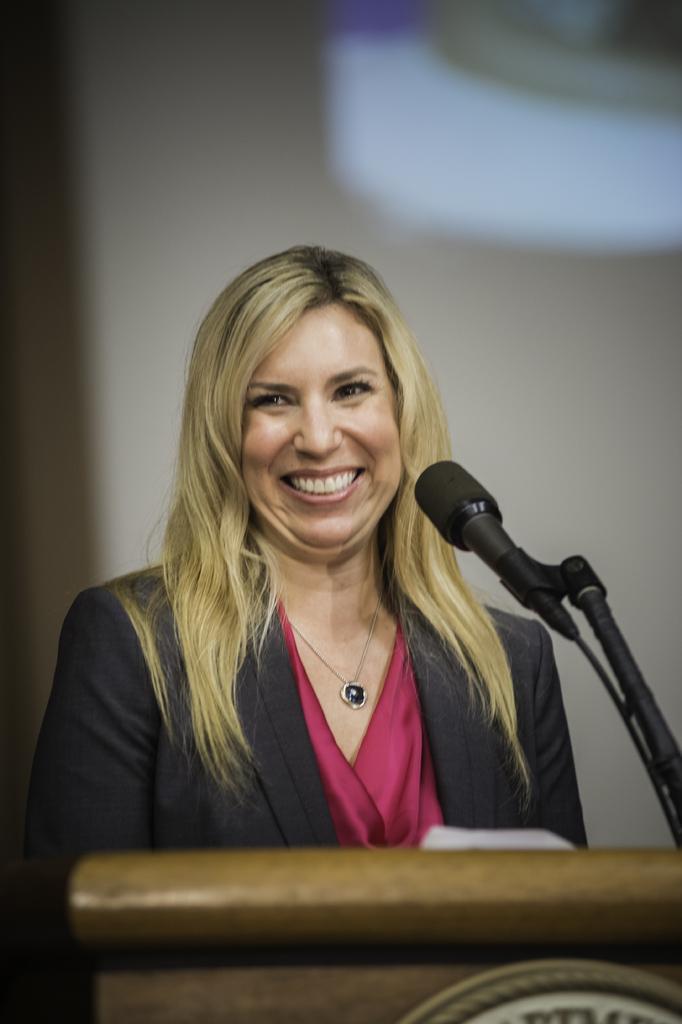Please provide a concise description of this image. In this picture there is a lady in the center of the image and there is a desk and a mic in front of her. 